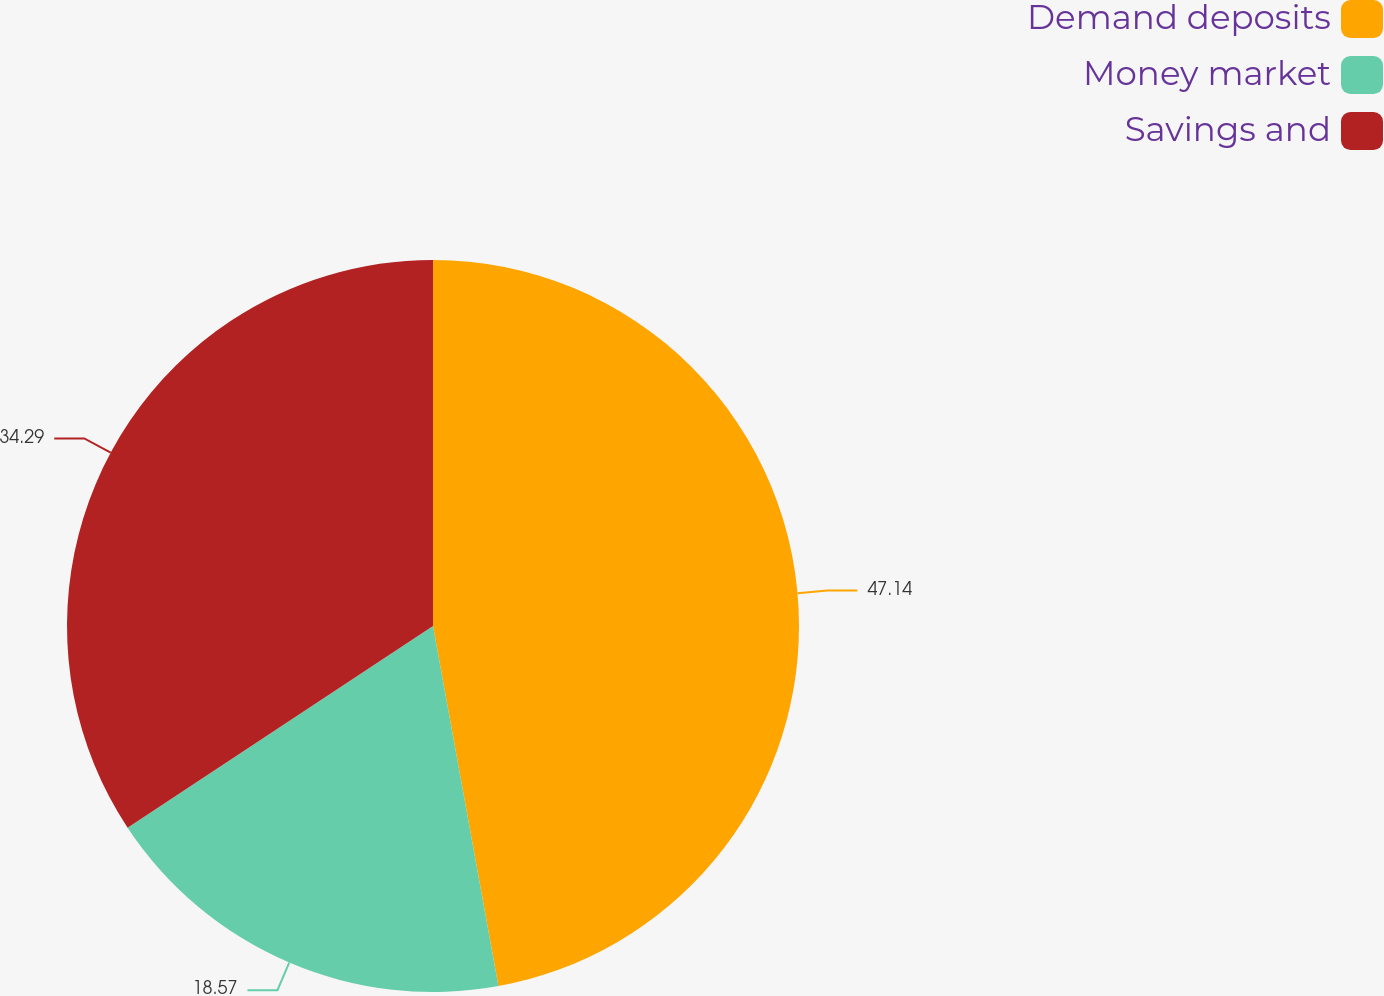<chart> <loc_0><loc_0><loc_500><loc_500><pie_chart><fcel>Demand deposits<fcel>Money market<fcel>Savings and<nl><fcel>47.14%<fcel>18.57%<fcel>34.29%<nl></chart> 